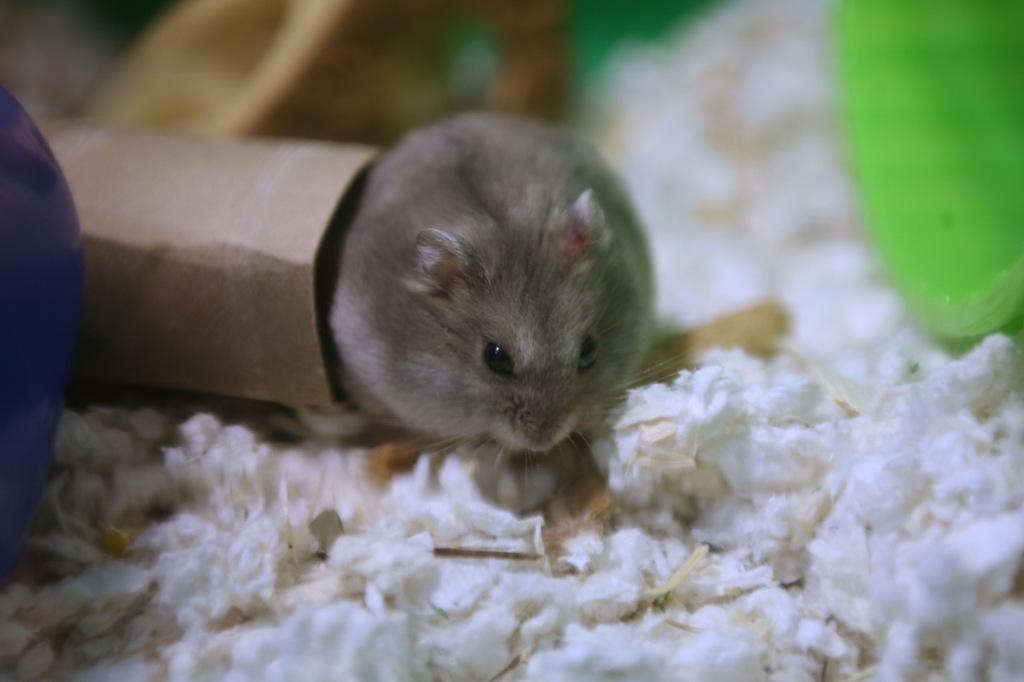What type of animal is present in the image? There is a mouse in the image. What is located on the right side of the mouse? There is a paper on the right side of the mouse. What color is the object at the bottom of the image? The object at the bottom of the image is white. How many spiders are crawling on the rule in the image? There are no spiders or rules present in the image. What type of can is visible in the image? There is no can present in the image. 